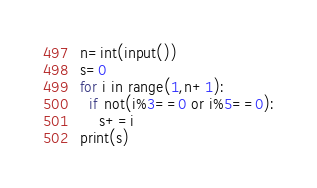<code> <loc_0><loc_0><loc_500><loc_500><_Python_>n=int(input())
s=0
for i in range(1,n+1):
  if not(i%3==0 or i%5==0):
    s+=i
print(s)</code> 